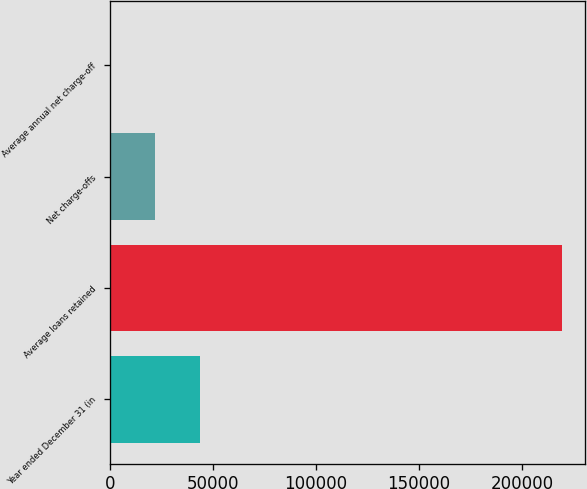Convert chart. <chart><loc_0><loc_0><loc_500><loc_500><bar_chart><fcel>Year ended December 31 (in<fcel>Average loans retained<fcel>Net charge-offs<fcel>Average annual net charge-off<nl><fcel>43922.5<fcel>219612<fcel>21961.4<fcel>0.18<nl></chart> 